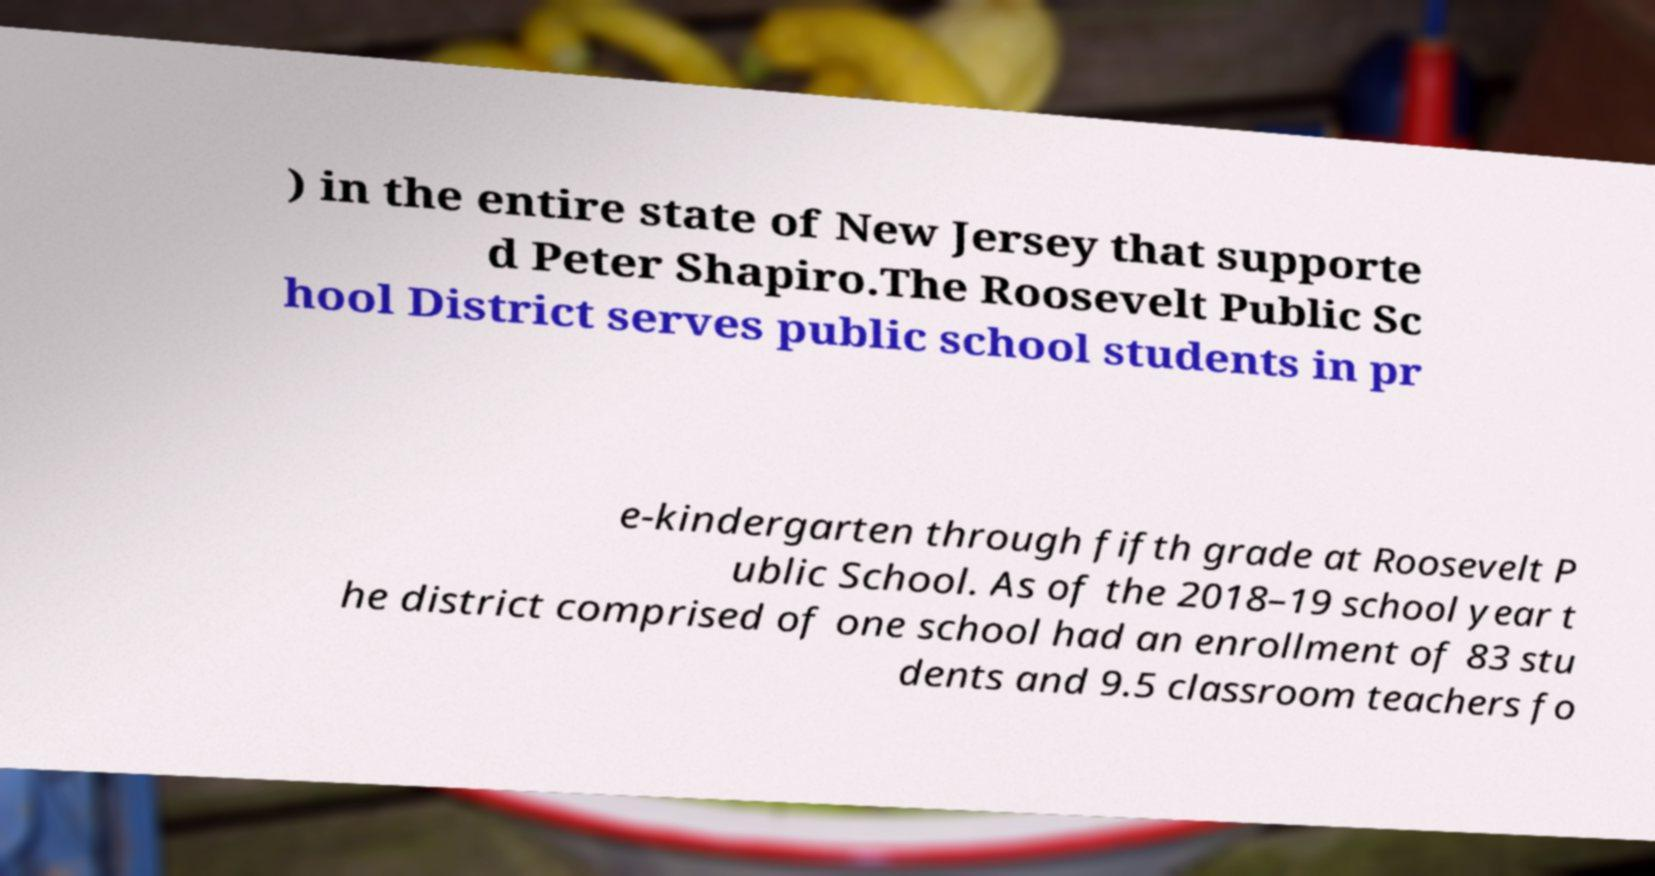Can you read and provide the text displayed in the image?This photo seems to have some interesting text. Can you extract and type it out for me? ) in the entire state of New Jersey that supporte d Peter Shapiro.The Roosevelt Public Sc hool District serves public school students in pr e-kindergarten through fifth grade at Roosevelt P ublic School. As of the 2018–19 school year t he district comprised of one school had an enrollment of 83 stu dents and 9.5 classroom teachers fo 